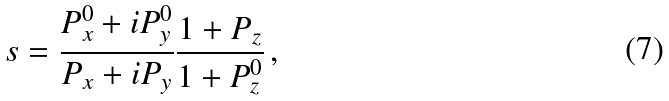Convert formula to latex. <formula><loc_0><loc_0><loc_500><loc_500>s = \frac { P _ { x } ^ { 0 } + i P _ { y } ^ { 0 } } { P _ { x } + i P _ { y } } \frac { 1 + P _ { z } } { 1 + P _ { z } ^ { 0 } } \, ,</formula> 